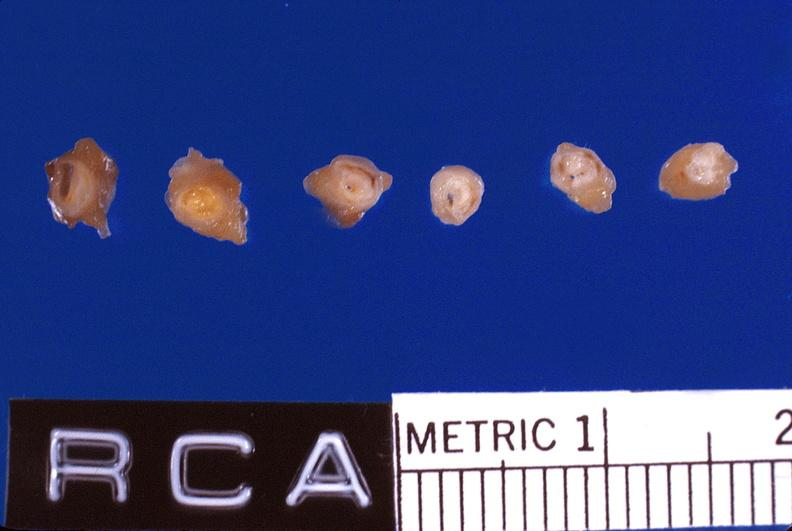what is present?
Answer the question using a single word or phrase. Cardiovascular 